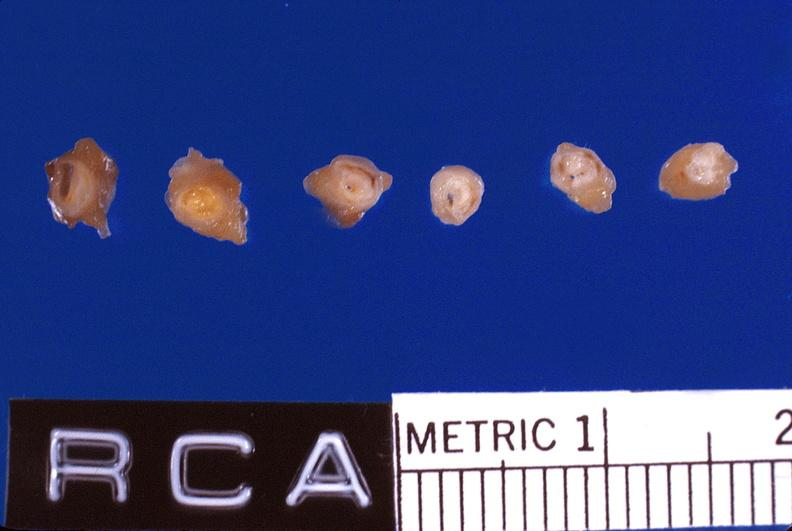what is present?
Answer the question using a single word or phrase. Cardiovascular 